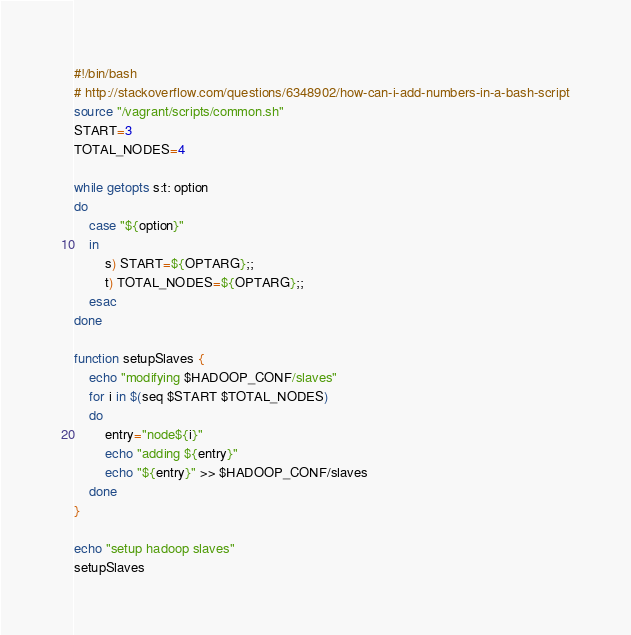<code> <loc_0><loc_0><loc_500><loc_500><_Bash_>#!/bin/bash
# http://stackoverflow.com/questions/6348902/how-can-i-add-numbers-in-a-bash-script
source "/vagrant/scripts/common.sh"
START=3
TOTAL_NODES=4

while getopts s:t: option
do
	case "${option}"
	in
		s) START=${OPTARG};;
		t) TOTAL_NODES=${OPTARG};;
	esac
done

function setupSlaves {
	echo "modifying $HADOOP_CONF/slaves"
	for i in $(seq $START $TOTAL_NODES)
	do 
		entry="node${i}"
		echo "adding ${entry}"
		echo "${entry}" >> $HADOOP_CONF/slaves
	done
}

echo "setup hadoop slaves"
setupSlaves</code> 